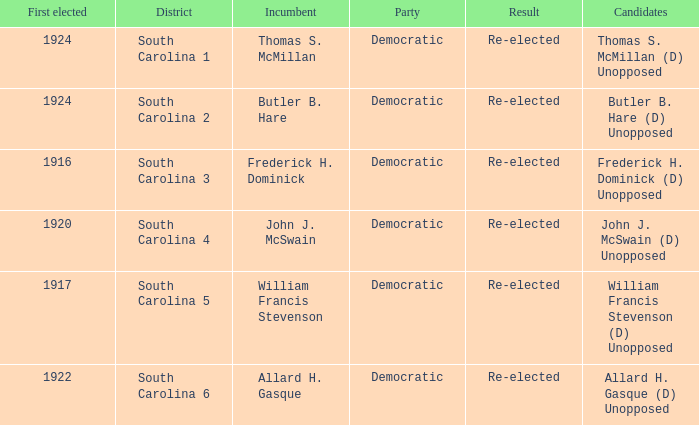What is the result for south carolina 4? Re-elected. 